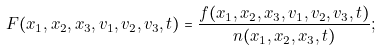<formula> <loc_0><loc_0><loc_500><loc_500>F ( x _ { 1 } , x _ { 2 } , x _ { 3 } , v _ { 1 } , v _ { 2 } , v _ { 3 } , t ) = \frac { f ( x _ { 1 } , x _ { 2 } , x _ { 3 } , v _ { 1 } , v _ { 2 } , v _ { 3 } , t ) } { n ( x _ { 1 } , x _ { 2 } , x _ { 3 } , t ) } ;</formula> 